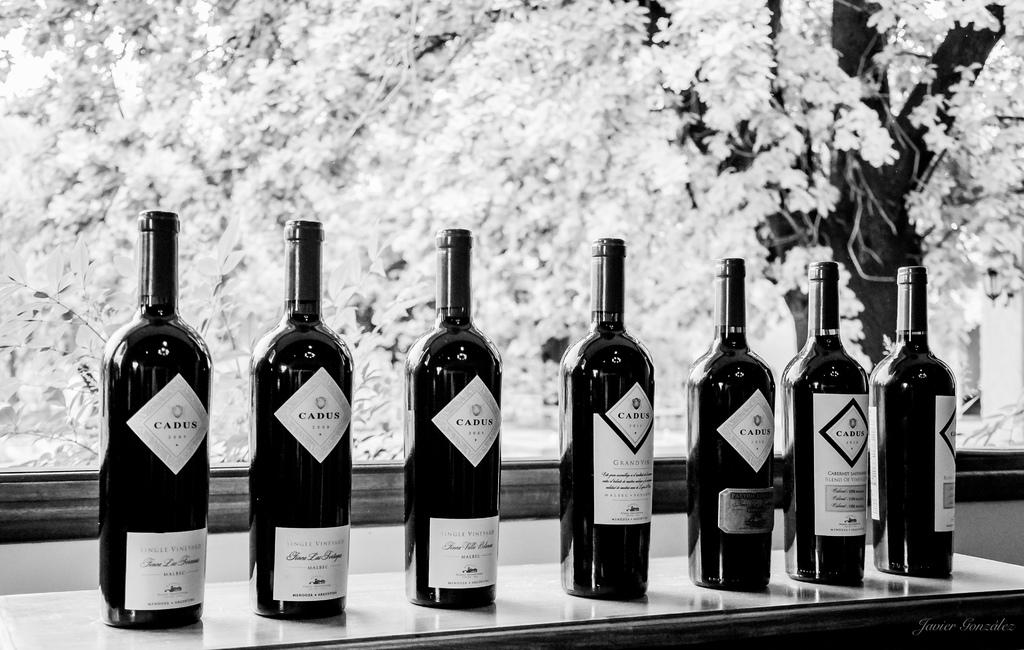<image>
Create a compact narrative representing the image presented. Seven bottles of Cadus wines are displayed neatly on a table. 